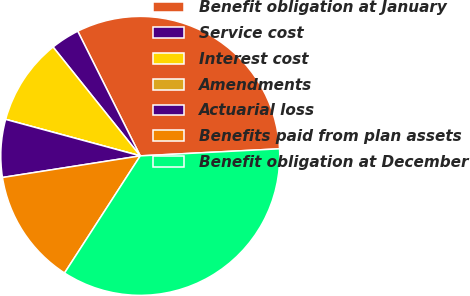Convert chart to OTSL. <chart><loc_0><loc_0><loc_500><loc_500><pie_chart><fcel>Benefit obligation at January<fcel>Service cost<fcel>Interest cost<fcel>Amendments<fcel>Actuarial loss<fcel>Benefits paid from plan assets<fcel>Benefit obligation at December<nl><fcel>31.59%<fcel>3.35%<fcel>10.04%<fcel>0.0%<fcel>6.69%<fcel>13.39%<fcel>34.94%<nl></chart> 